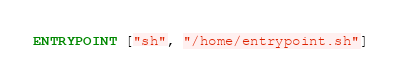Convert code to text. <code><loc_0><loc_0><loc_500><loc_500><_Dockerfile_>ENTRYPOINT ["sh", "/home/entrypoint.sh"]
</code> 